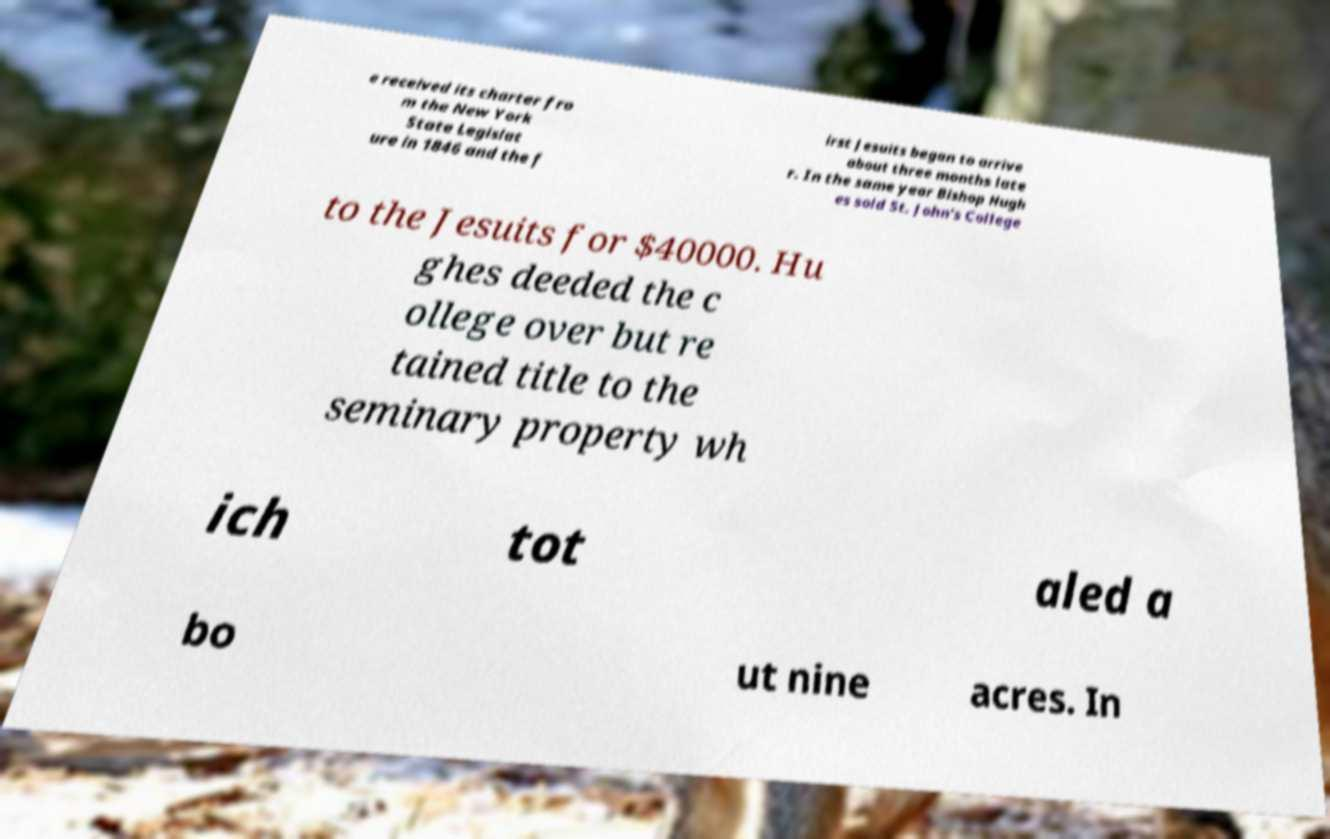Can you accurately transcribe the text from the provided image for me? e received its charter fro m the New York State Legislat ure in 1846 and the f irst Jesuits began to arrive about three months late r. In the same year Bishop Hugh es sold St. John's College to the Jesuits for $40000. Hu ghes deeded the c ollege over but re tained title to the seminary property wh ich tot aled a bo ut nine acres. In 